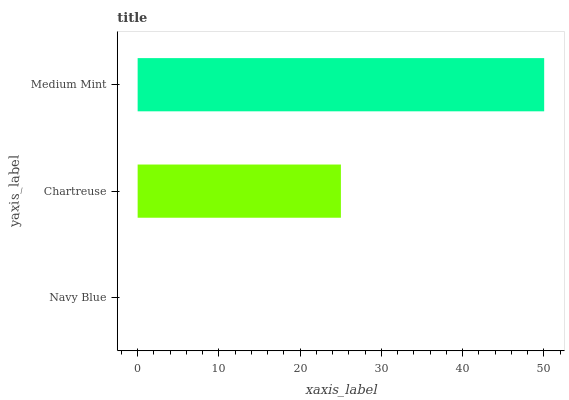Is Navy Blue the minimum?
Answer yes or no. Yes. Is Medium Mint the maximum?
Answer yes or no. Yes. Is Chartreuse the minimum?
Answer yes or no. No. Is Chartreuse the maximum?
Answer yes or no. No. Is Chartreuse greater than Navy Blue?
Answer yes or no. Yes. Is Navy Blue less than Chartreuse?
Answer yes or no. Yes. Is Navy Blue greater than Chartreuse?
Answer yes or no. No. Is Chartreuse less than Navy Blue?
Answer yes or no. No. Is Chartreuse the high median?
Answer yes or no. Yes. Is Chartreuse the low median?
Answer yes or no. Yes. Is Medium Mint the high median?
Answer yes or no. No. Is Medium Mint the low median?
Answer yes or no. No. 